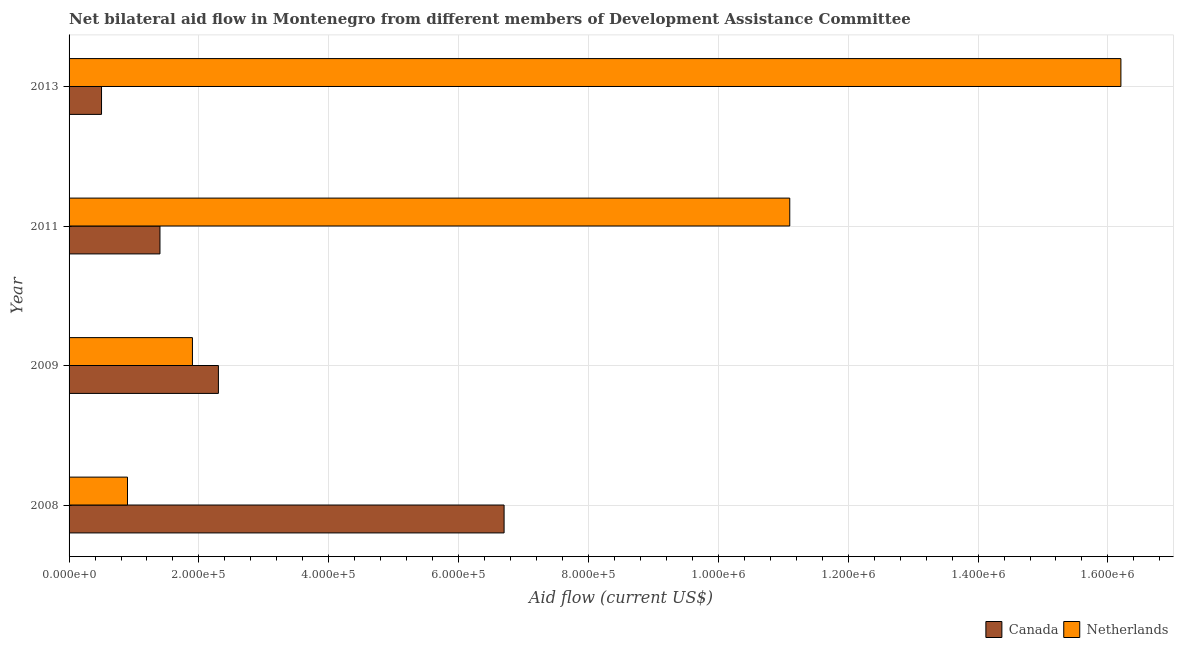Are the number of bars on each tick of the Y-axis equal?
Your answer should be very brief. Yes. What is the amount of aid given by netherlands in 2011?
Your response must be concise. 1.11e+06. Across all years, what is the maximum amount of aid given by netherlands?
Provide a short and direct response. 1.62e+06. Across all years, what is the minimum amount of aid given by netherlands?
Provide a succinct answer. 9.00e+04. What is the total amount of aid given by canada in the graph?
Ensure brevity in your answer.  1.09e+06. What is the difference between the amount of aid given by canada in 2009 and that in 2011?
Ensure brevity in your answer.  9.00e+04. What is the difference between the amount of aid given by netherlands in 2008 and the amount of aid given by canada in 2011?
Make the answer very short. -5.00e+04. What is the average amount of aid given by netherlands per year?
Keep it short and to the point. 7.52e+05. In the year 2011, what is the difference between the amount of aid given by netherlands and amount of aid given by canada?
Provide a short and direct response. 9.70e+05. What is the ratio of the amount of aid given by canada in 2008 to that in 2011?
Offer a very short reply. 4.79. Is the difference between the amount of aid given by canada in 2011 and 2013 greater than the difference between the amount of aid given by netherlands in 2011 and 2013?
Make the answer very short. Yes. What is the difference between the highest and the lowest amount of aid given by canada?
Make the answer very short. 6.20e+05. Is the sum of the amount of aid given by canada in 2008 and 2009 greater than the maximum amount of aid given by netherlands across all years?
Offer a terse response. No. What does the 1st bar from the top in 2008 represents?
Your answer should be compact. Netherlands. Are all the bars in the graph horizontal?
Keep it short and to the point. Yes. How many years are there in the graph?
Give a very brief answer. 4. Are the values on the major ticks of X-axis written in scientific E-notation?
Your answer should be compact. Yes. Where does the legend appear in the graph?
Your answer should be compact. Bottom right. How many legend labels are there?
Your response must be concise. 2. What is the title of the graph?
Give a very brief answer. Net bilateral aid flow in Montenegro from different members of Development Assistance Committee. Does "IMF nonconcessional" appear as one of the legend labels in the graph?
Your answer should be very brief. No. What is the label or title of the Y-axis?
Your answer should be compact. Year. What is the Aid flow (current US$) of Canada in 2008?
Offer a very short reply. 6.70e+05. What is the Aid flow (current US$) of Netherlands in 2008?
Ensure brevity in your answer.  9.00e+04. What is the Aid flow (current US$) of Canada in 2009?
Your response must be concise. 2.30e+05. What is the Aid flow (current US$) in Netherlands in 2009?
Ensure brevity in your answer.  1.90e+05. What is the Aid flow (current US$) in Canada in 2011?
Provide a succinct answer. 1.40e+05. What is the Aid flow (current US$) in Netherlands in 2011?
Make the answer very short. 1.11e+06. What is the Aid flow (current US$) of Canada in 2013?
Offer a terse response. 5.00e+04. What is the Aid flow (current US$) of Netherlands in 2013?
Keep it short and to the point. 1.62e+06. Across all years, what is the maximum Aid flow (current US$) in Canada?
Ensure brevity in your answer.  6.70e+05. Across all years, what is the maximum Aid flow (current US$) of Netherlands?
Your answer should be very brief. 1.62e+06. Across all years, what is the minimum Aid flow (current US$) of Canada?
Offer a terse response. 5.00e+04. Across all years, what is the minimum Aid flow (current US$) of Netherlands?
Offer a very short reply. 9.00e+04. What is the total Aid flow (current US$) of Canada in the graph?
Ensure brevity in your answer.  1.09e+06. What is the total Aid flow (current US$) of Netherlands in the graph?
Provide a short and direct response. 3.01e+06. What is the difference between the Aid flow (current US$) of Netherlands in 2008 and that in 2009?
Give a very brief answer. -1.00e+05. What is the difference between the Aid flow (current US$) in Canada in 2008 and that in 2011?
Your answer should be compact. 5.30e+05. What is the difference between the Aid flow (current US$) of Netherlands in 2008 and that in 2011?
Make the answer very short. -1.02e+06. What is the difference between the Aid flow (current US$) in Canada in 2008 and that in 2013?
Provide a succinct answer. 6.20e+05. What is the difference between the Aid flow (current US$) of Netherlands in 2008 and that in 2013?
Ensure brevity in your answer.  -1.53e+06. What is the difference between the Aid flow (current US$) in Netherlands in 2009 and that in 2011?
Provide a short and direct response. -9.20e+05. What is the difference between the Aid flow (current US$) of Netherlands in 2009 and that in 2013?
Your answer should be compact. -1.43e+06. What is the difference between the Aid flow (current US$) of Netherlands in 2011 and that in 2013?
Give a very brief answer. -5.10e+05. What is the difference between the Aid flow (current US$) of Canada in 2008 and the Aid flow (current US$) of Netherlands in 2009?
Give a very brief answer. 4.80e+05. What is the difference between the Aid flow (current US$) of Canada in 2008 and the Aid flow (current US$) of Netherlands in 2011?
Keep it short and to the point. -4.40e+05. What is the difference between the Aid flow (current US$) of Canada in 2008 and the Aid flow (current US$) of Netherlands in 2013?
Your answer should be very brief. -9.50e+05. What is the difference between the Aid flow (current US$) in Canada in 2009 and the Aid flow (current US$) in Netherlands in 2011?
Make the answer very short. -8.80e+05. What is the difference between the Aid flow (current US$) of Canada in 2009 and the Aid flow (current US$) of Netherlands in 2013?
Make the answer very short. -1.39e+06. What is the difference between the Aid flow (current US$) of Canada in 2011 and the Aid flow (current US$) of Netherlands in 2013?
Your response must be concise. -1.48e+06. What is the average Aid flow (current US$) of Canada per year?
Provide a succinct answer. 2.72e+05. What is the average Aid flow (current US$) of Netherlands per year?
Provide a short and direct response. 7.52e+05. In the year 2008, what is the difference between the Aid flow (current US$) of Canada and Aid flow (current US$) of Netherlands?
Provide a succinct answer. 5.80e+05. In the year 2009, what is the difference between the Aid flow (current US$) of Canada and Aid flow (current US$) of Netherlands?
Your response must be concise. 4.00e+04. In the year 2011, what is the difference between the Aid flow (current US$) of Canada and Aid flow (current US$) of Netherlands?
Your answer should be very brief. -9.70e+05. In the year 2013, what is the difference between the Aid flow (current US$) of Canada and Aid flow (current US$) of Netherlands?
Offer a very short reply. -1.57e+06. What is the ratio of the Aid flow (current US$) of Canada in 2008 to that in 2009?
Your answer should be very brief. 2.91. What is the ratio of the Aid flow (current US$) of Netherlands in 2008 to that in 2009?
Your answer should be compact. 0.47. What is the ratio of the Aid flow (current US$) in Canada in 2008 to that in 2011?
Offer a very short reply. 4.79. What is the ratio of the Aid flow (current US$) of Netherlands in 2008 to that in 2011?
Offer a very short reply. 0.08. What is the ratio of the Aid flow (current US$) of Netherlands in 2008 to that in 2013?
Your answer should be very brief. 0.06. What is the ratio of the Aid flow (current US$) in Canada in 2009 to that in 2011?
Ensure brevity in your answer.  1.64. What is the ratio of the Aid flow (current US$) of Netherlands in 2009 to that in 2011?
Ensure brevity in your answer.  0.17. What is the ratio of the Aid flow (current US$) of Netherlands in 2009 to that in 2013?
Provide a succinct answer. 0.12. What is the ratio of the Aid flow (current US$) in Netherlands in 2011 to that in 2013?
Your response must be concise. 0.69. What is the difference between the highest and the second highest Aid flow (current US$) in Netherlands?
Offer a very short reply. 5.10e+05. What is the difference between the highest and the lowest Aid flow (current US$) of Canada?
Keep it short and to the point. 6.20e+05. What is the difference between the highest and the lowest Aid flow (current US$) in Netherlands?
Ensure brevity in your answer.  1.53e+06. 